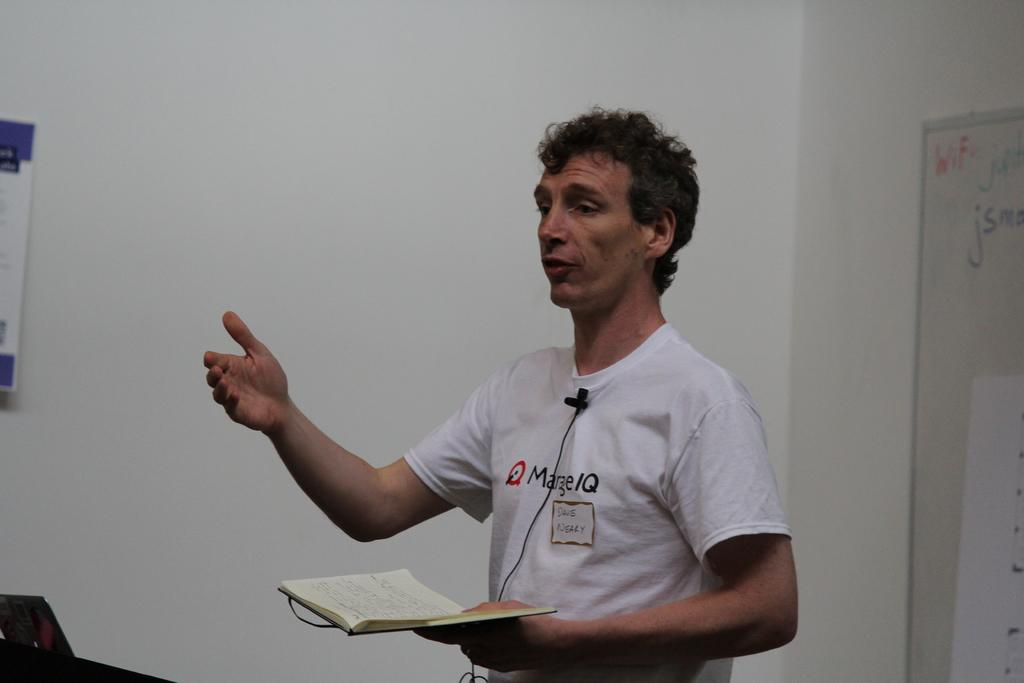<image>
Offer a succinct explanation of the picture presented. Speaker wearing a white tshirt and a name tag of Dajs Neary. 